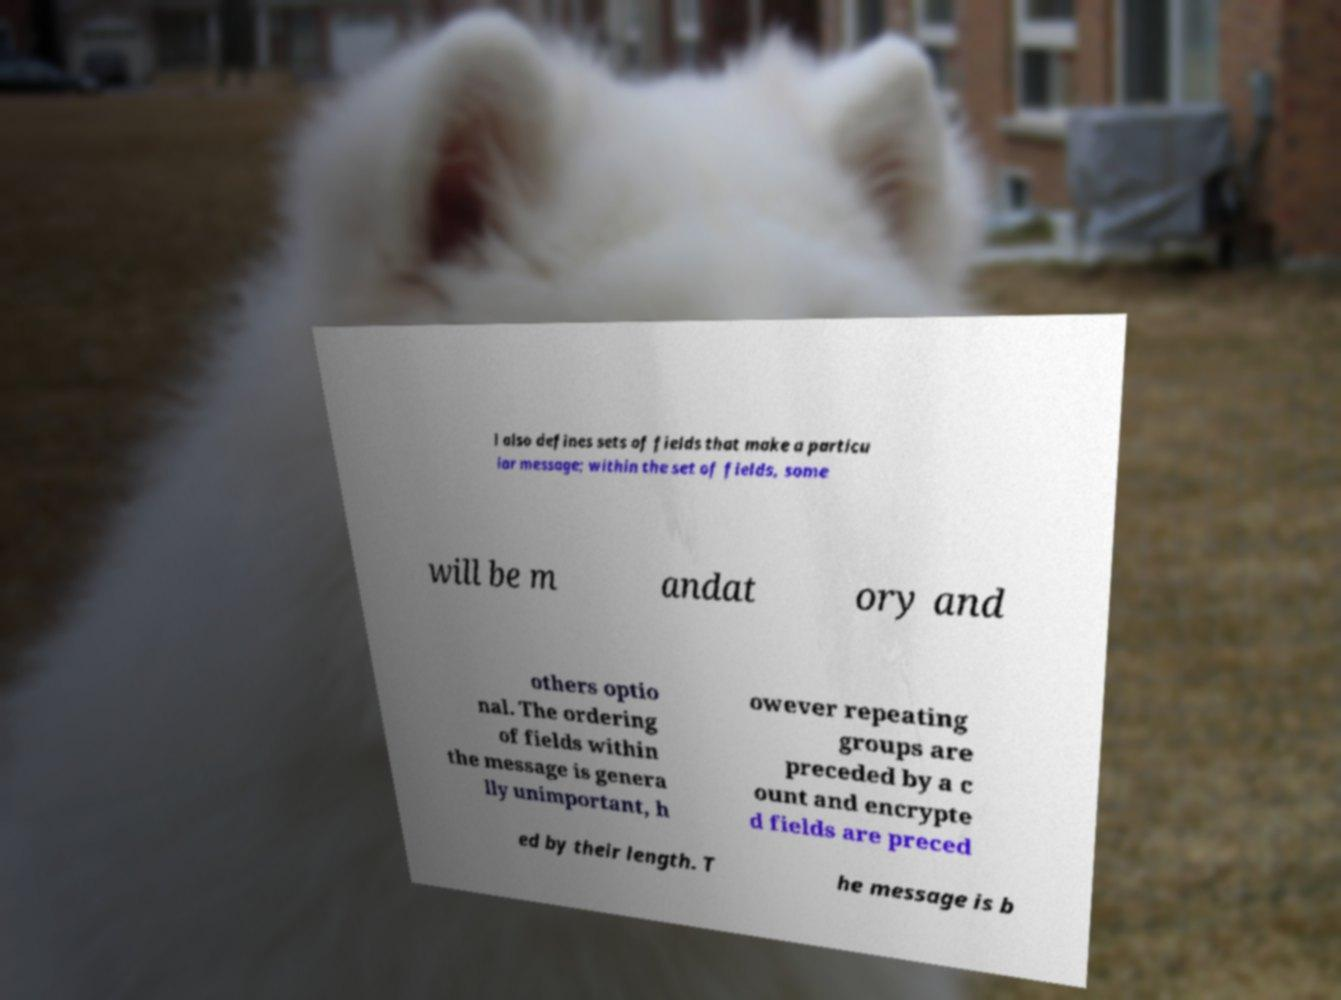Please read and relay the text visible in this image. What does it say? l also defines sets of fields that make a particu lar message; within the set of fields, some will be m andat ory and others optio nal. The ordering of fields within the message is genera lly unimportant, h owever repeating groups are preceded by a c ount and encrypte d fields are preced ed by their length. T he message is b 